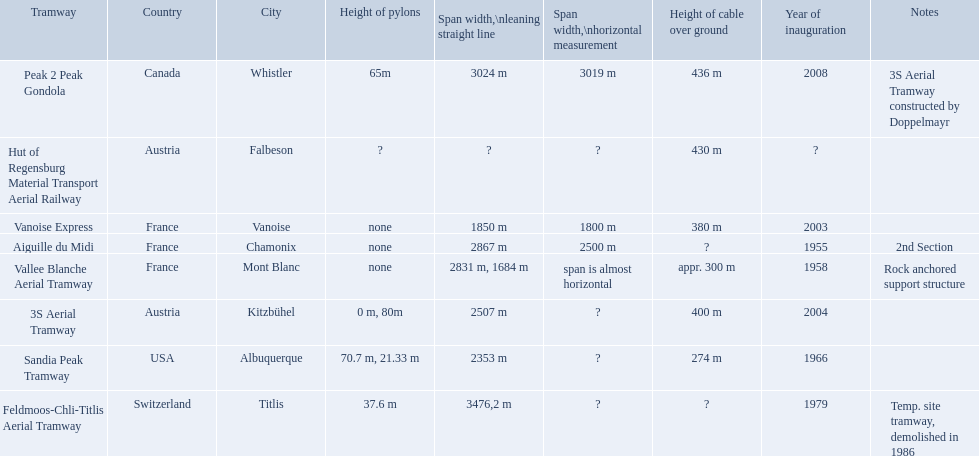Which tramways are in france? Vanoise Express, Aiguille du Midi, Vallee Blanche Aerial Tramway. Which of those were inaugurated in the 1950? Aiguille du Midi, Vallee Blanche Aerial Tramway. Which of these tramways span is not almost horizontal? Aiguille du Midi. What are all of the tramways? Peak 2 Peak Gondola, Hut of Regensburg Material Transport Aerial Railway, Vanoise Express, Aiguille du Midi, Vallee Blanche Aerial Tramway, 3S Aerial Tramway, Sandia Peak Tramway, Feldmoos-Chli-Titlis Aerial Tramway. When were they inaugurated? 2008, ?, 2003, 1955, 1958, 2004, 1966, 1979. Now, between 3s aerial tramway and aiguille du midi, which was inaugurated first? Aiguille du Midi. What are all of the aerial tram systems? Peak 2 Peak Gondola, Hut of Regensburg Material Transport Aerial Railway, Vanoise Express, Aiguille du Midi, Vallee Blanche Aerial Tramway, 3S Aerial Tramway, Sandia Peak Tramway, Feldmoos-Chli-Titlis Aerial Tramway. When were they established? 2008, ?, 2003, 1955, 1958, 2004, 1966, 1979. Now, between 3s aerial tram system and aiguille du midi, which was established first? Aiguille du Midi. 